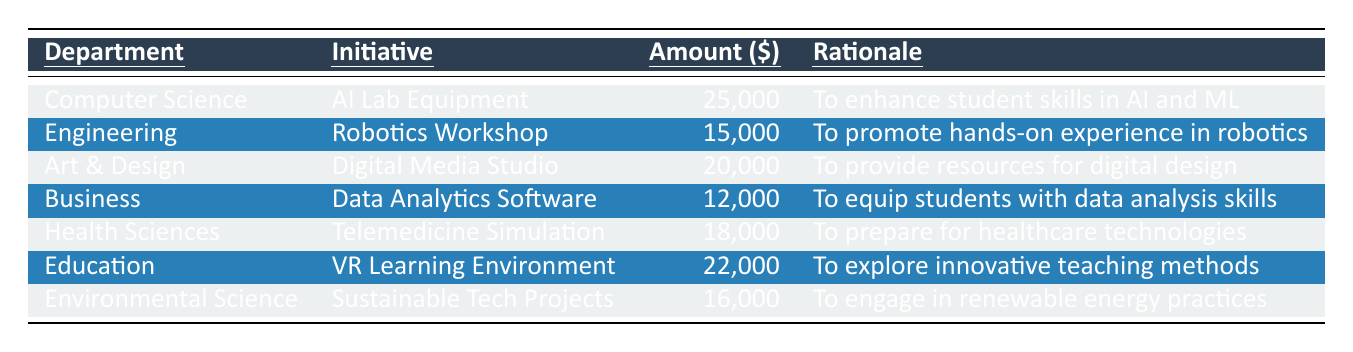What is the total amount allocated for the Health Sciences department? The table shows that the allocated amount for the Health Sciences department is $18,000.
Answer: 18,000 Which initiative received the highest funding? The table indicates that the "AI Lab Equipment" initiative in the Computer Science department received the highest funding of $25,000.
Answer: AI Lab Equipment What is the allocated amount for the Business department? According to the table, the Business department received an allocated amount of $12,000 for the "Data Analytics Software" initiative.
Answer: 12,000 How much more funding was allocated to the Education department compared to the Engineering department? The Education department received $22,000 and the Engineering department received $15,000. The difference is $22,000 - $15,000 = $7,000.
Answer: 7,000 Is the rationale for the Environmental Science initiative related to technology? The rationale listed for the Environmental Science initiative is to engage students in renewable energy and sustainable practices, which indicates a connection to technology.
Answer: Yes What is the average funding allocated across all departments? The total funding allocated is $25,000 + $15,000 + $20,000 + $12,000 + $18,000 + $22,000 + $16,000 = $128,000. Since there are 7 departments, the average is $128,000 / 7 = approximately $18,286.
Answer: 18,286 How many initiatives received an allocation of $20,000 or more? The initiatives with $20,000 or more are the "AI Lab Equipment," "Digital Media Studio," and "VR Learning Environment." That's 3 initiatives.
Answer: 3 Which department has the least funding allocated? The Business department has the least funding with $12,000 allocated for its initiative, which is lower than all the other departments.
Answer: Business What is the total amount allocated to initiatives related to technology in Education, Health Sciences, and Computer Science? The amounts for the mentioned departments are: Education ($22,000), Health Sciences ($18,000), and Computer Science ($25,000). Summing these gives $22,000 + $18,000 + $25,000 = $65,000.
Answer: 65,000 